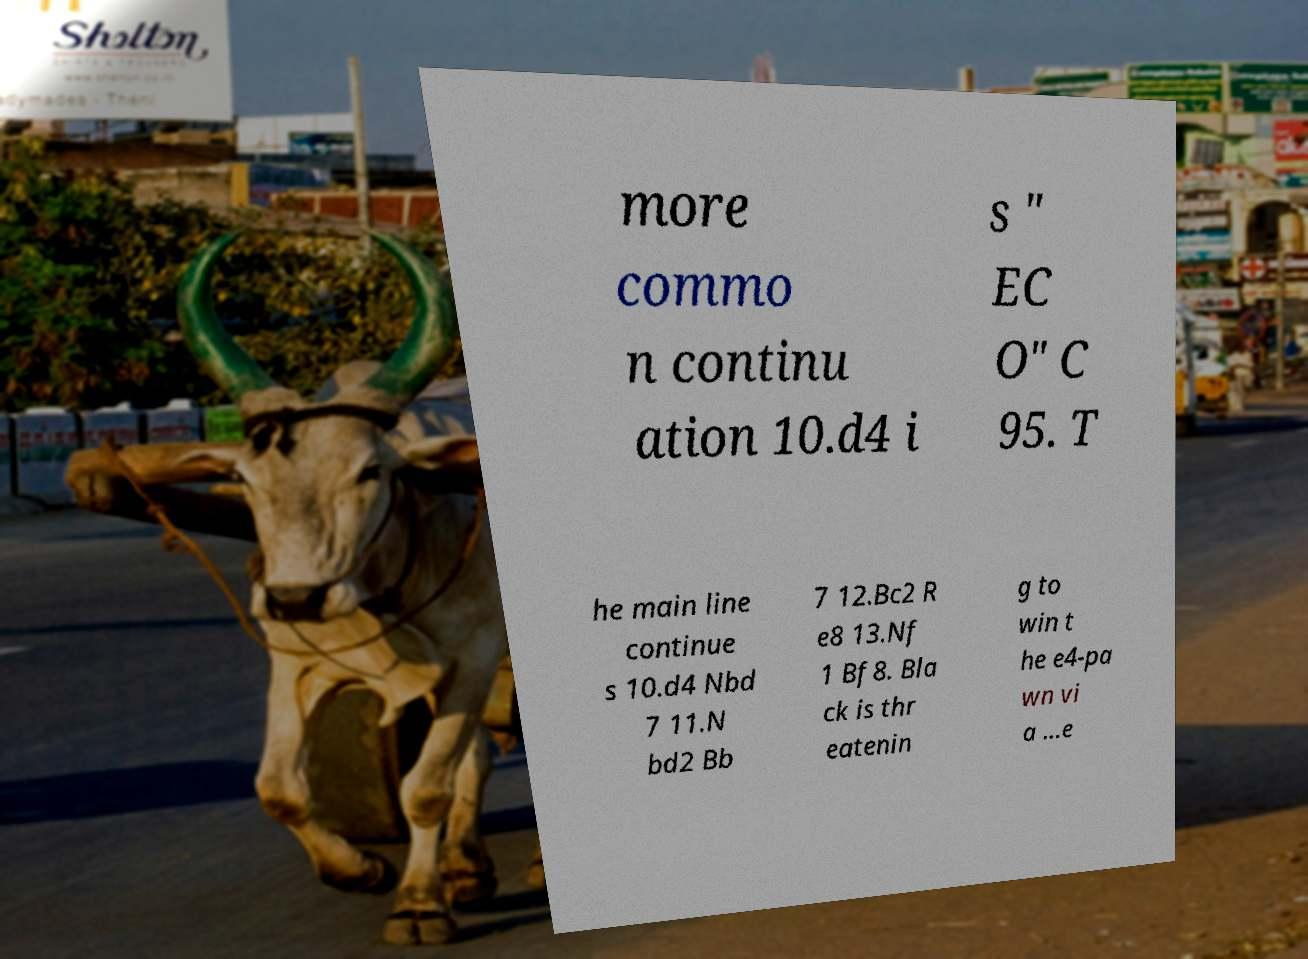For documentation purposes, I need the text within this image transcribed. Could you provide that? more commo n continu ation 10.d4 i s " EC O" C 95. T he main line continue s 10.d4 Nbd 7 11.N bd2 Bb 7 12.Bc2 R e8 13.Nf 1 Bf8. Bla ck is thr eatenin g to win t he e4-pa wn vi a ...e 